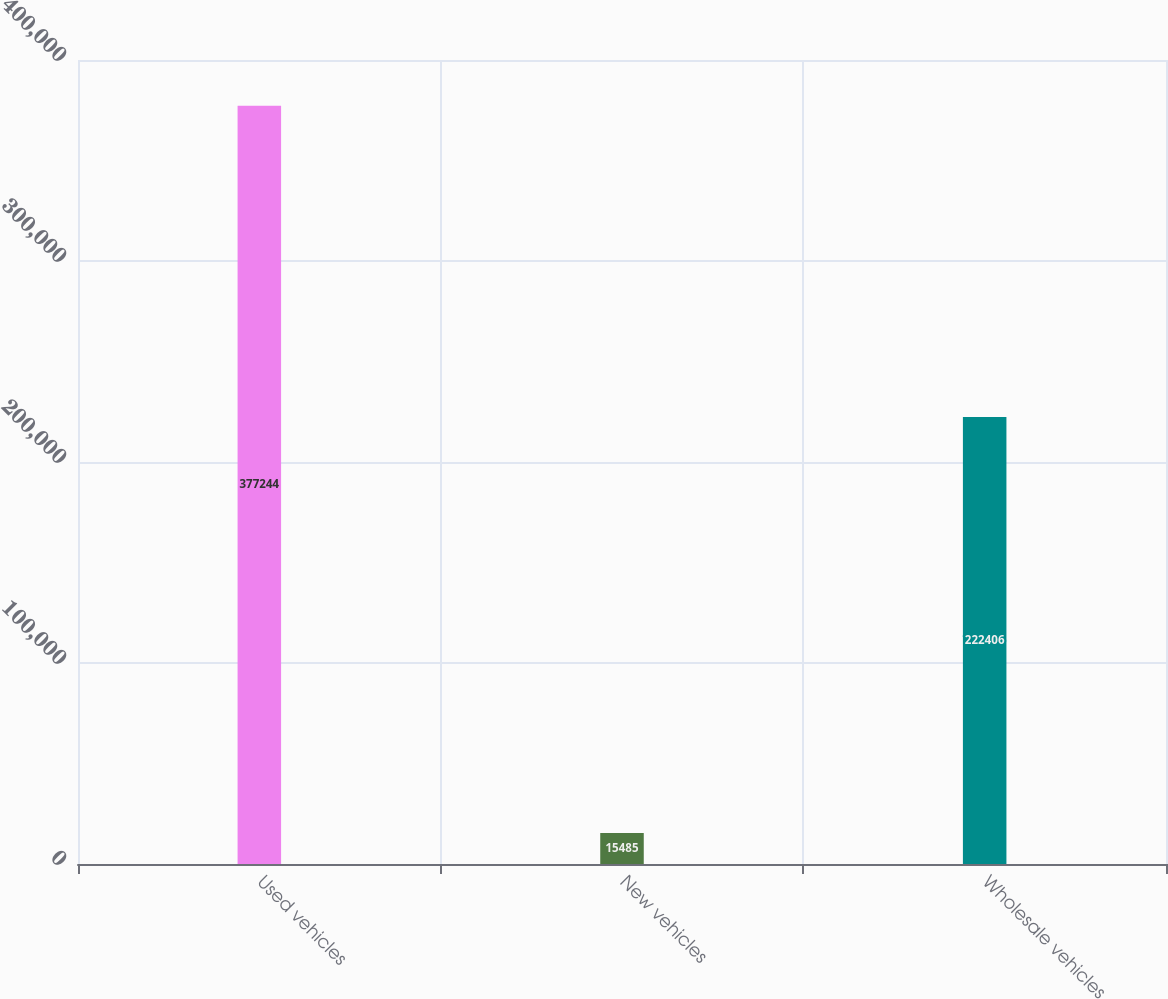<chart> <loc_0><loc_0><loc_500><loc_500><bar_chart><fcel>Used vehicles<fcel>New vehicles<fcel>Wholesale vehicles<nl><fcel>377244<fcel>15485<fcel>222406<nl></chart> 